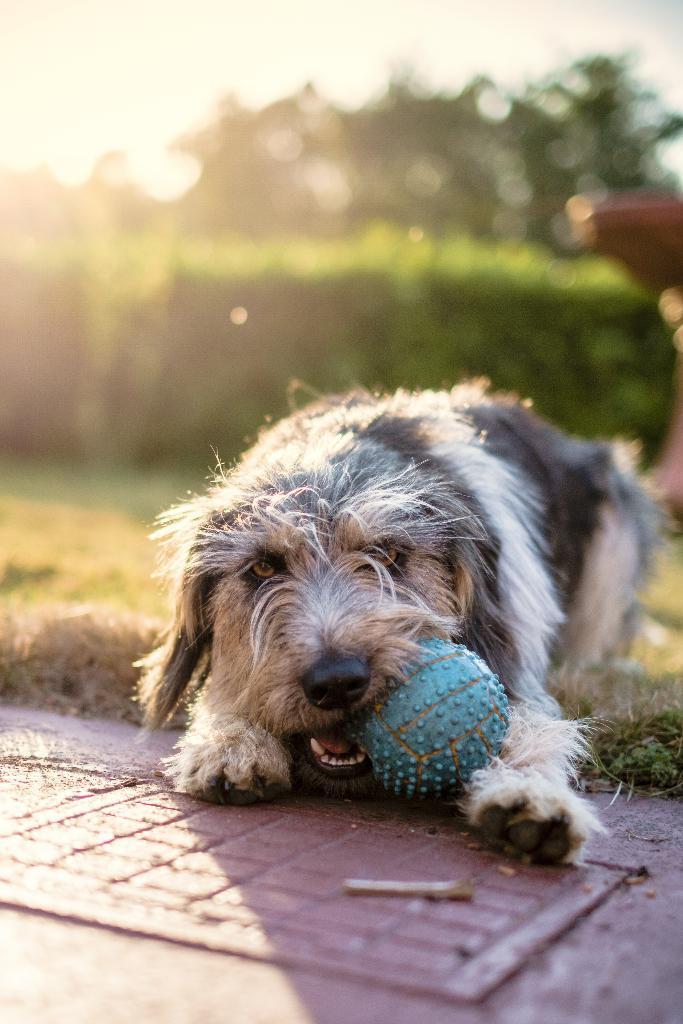Please provide a concise description of this image. In this image we can see a dog holding a ball and there is a grass on the ground and in the background, the image is blurred. 